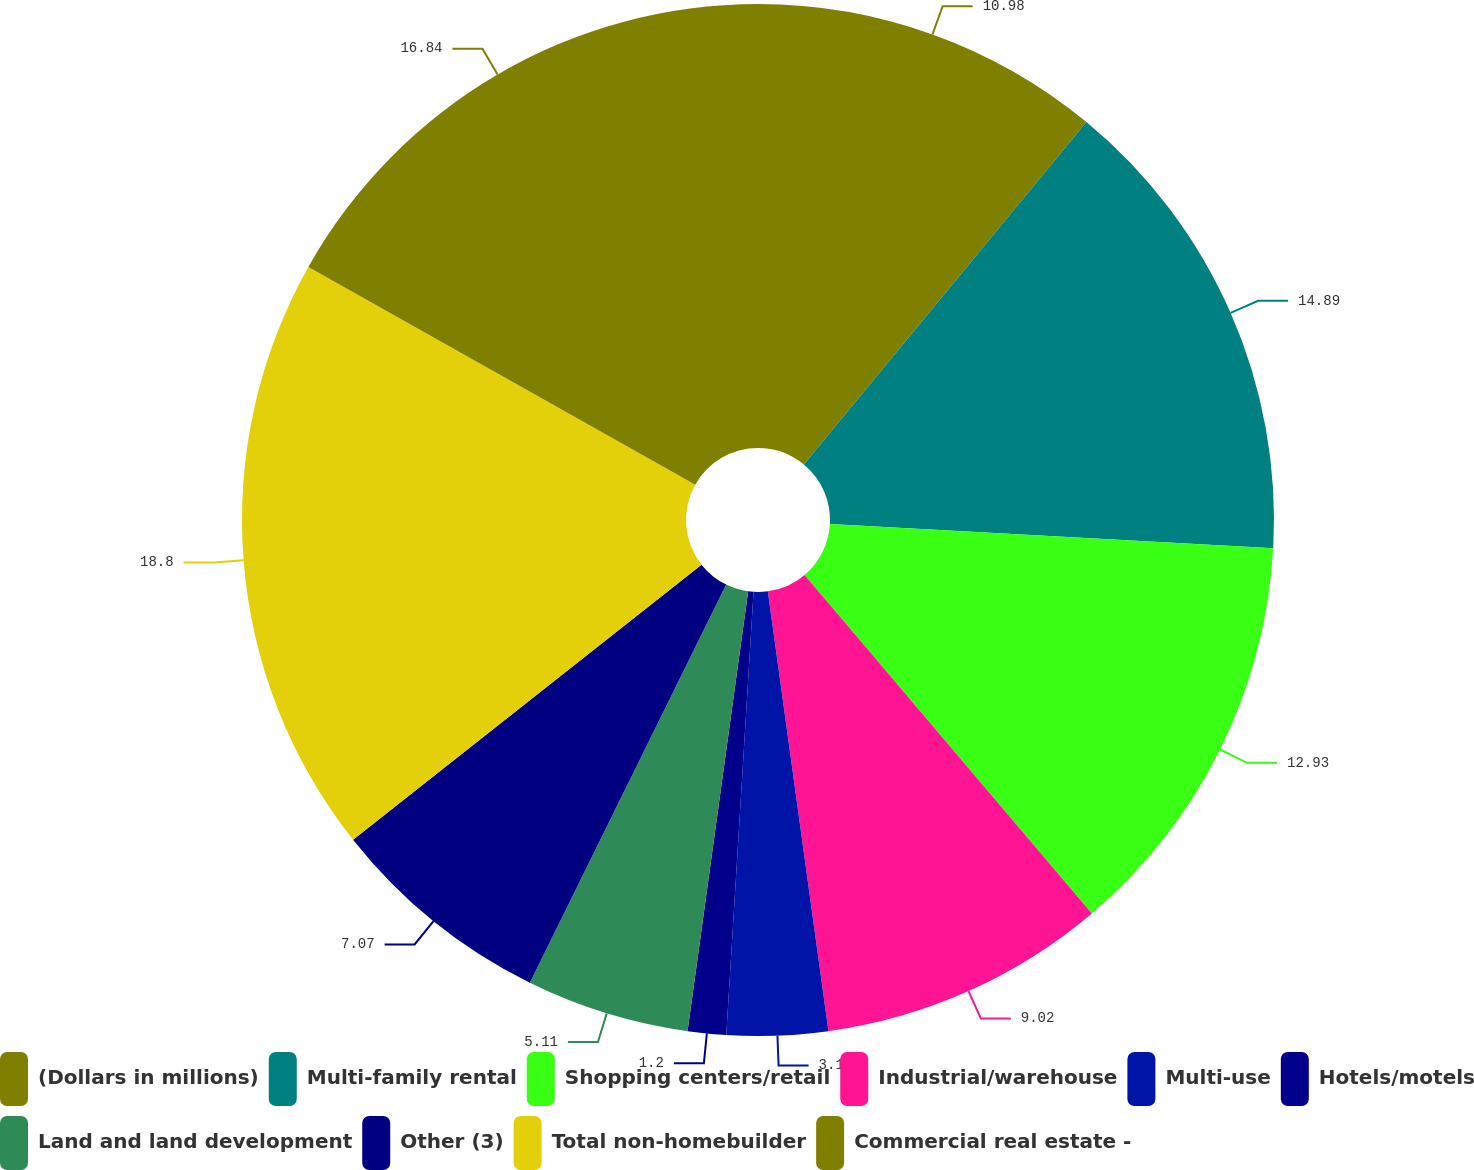<chart> <loc_0><loc_0><loc_500><loc_500><pie_chart><fcel>(Dollars in millions)<fcel>Multi-family rental<fcel>Shopping centers/retail<fcel>Industrial/warehouse<fcel>Multi-use<fcel>Hotels/motels<fcel>Land and land development<fcel>Other (3)<fcel>Total non-homebuilder<fcel>Commercial real estate -<nl><fcel>10.98%<fcel>14.89%<fcel>12.93%<fcel>9.02%<fcel>3.16%<fcel>1.2%<fcel>5.11%<fcel>7.07%<fcel>18.8%<fcel>16.84%<nl></chart> 